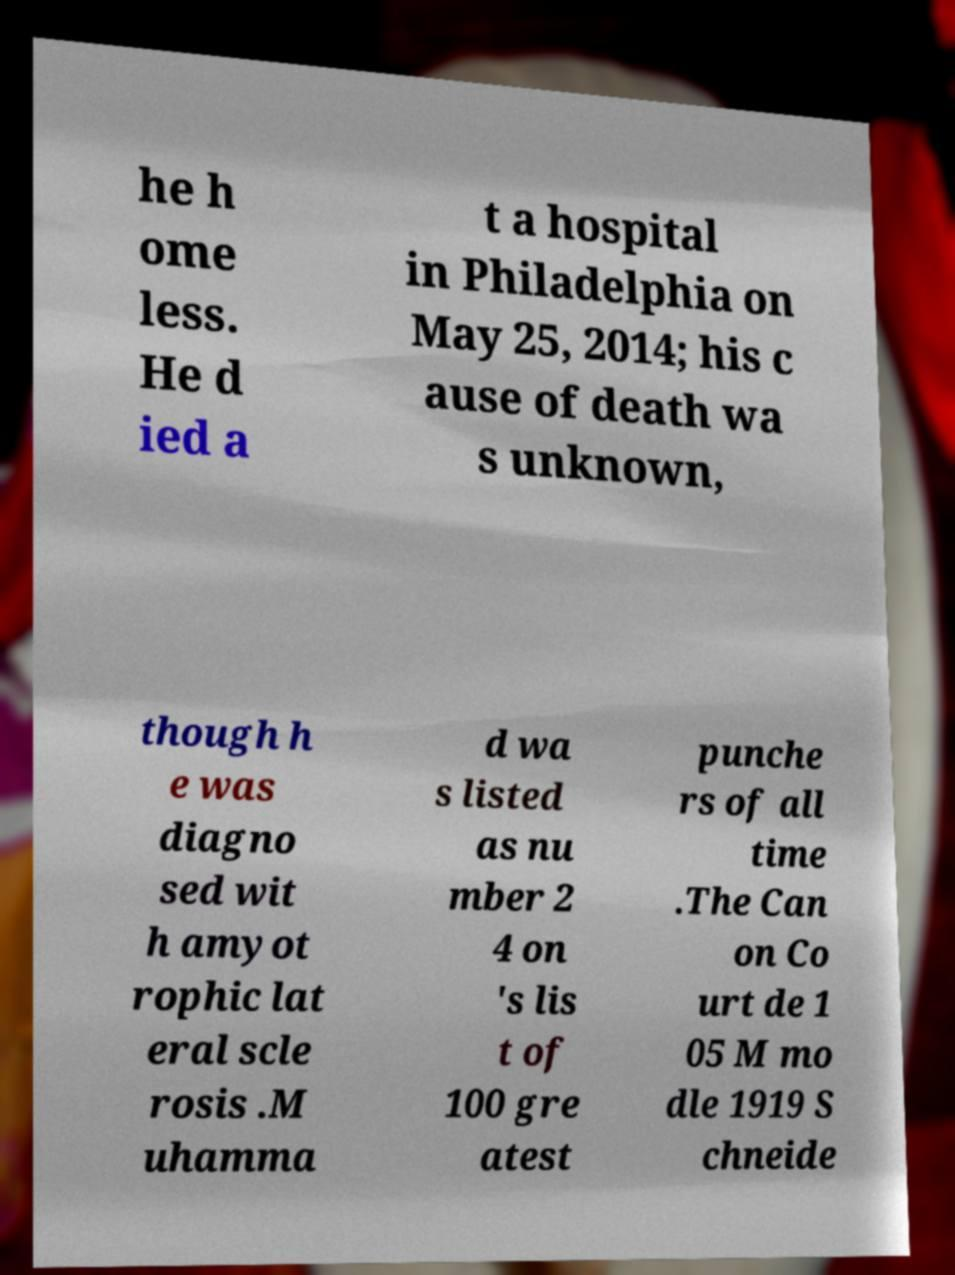Please identify and transcribe the text found in this image. he h ome less. He d ied a t a hospital in Philadelphia on May 25, 2014; his c ause of death wa s unknown, though h e was diagno sed wit h amyot rophic lat eral scle rosis .M uhamma d wa s listed as nu mber 2 4 on 's lis t of 100 gre atest punche rs of all time .The Can on Co urt de 1 05 M mo dle 1919 S chneide 